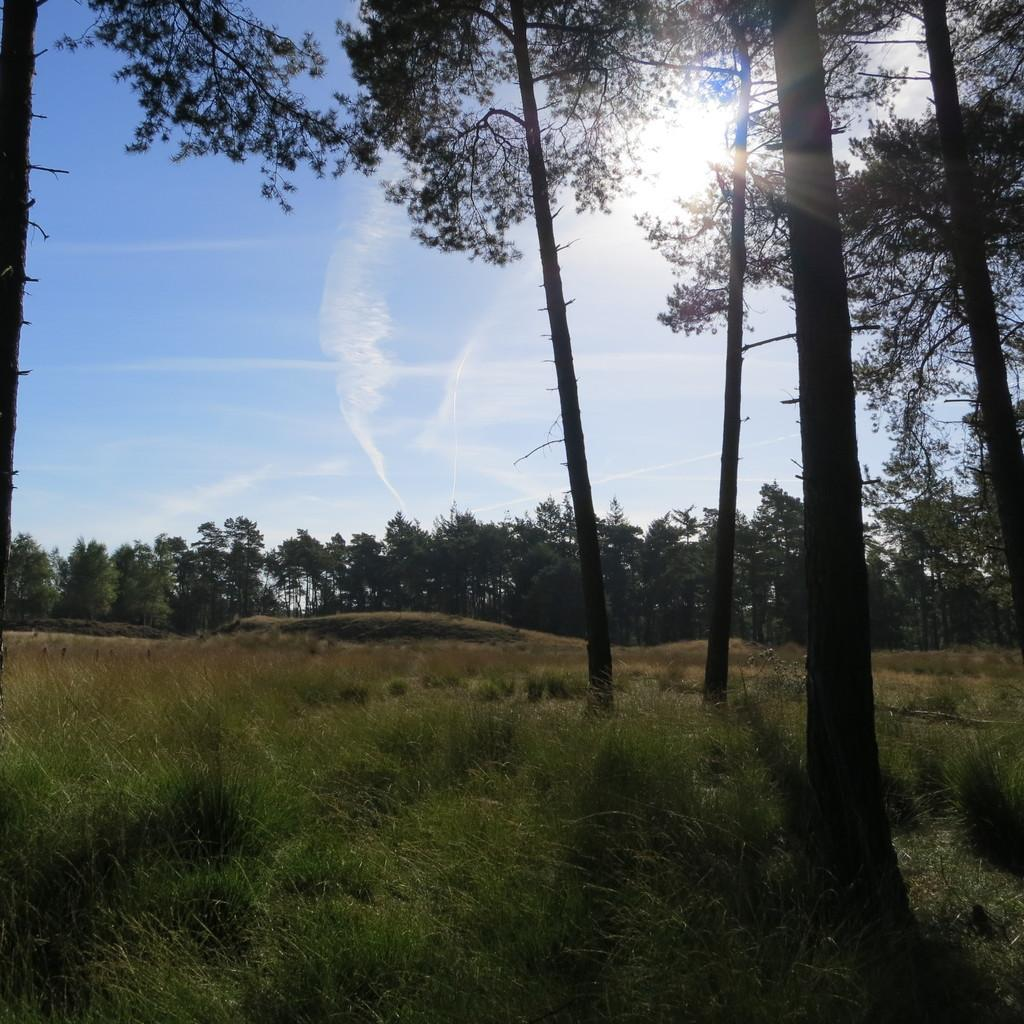What type of vegetation is at the bottom of the image? There is grass at the bottom of the image. What can be seen at the top of the image? There are trees at the top of the image. What is visible in the sky at the top of the image? The sky is visible at the top of the image, and the sun is observable in the sky. How many yams are placed next to the trees in the image? There are no yams present in the image; it features grass, trees, and the sky. What type of toys can be seen in the image? There are no toys present in the image; it features grass, trees, and the sky. 